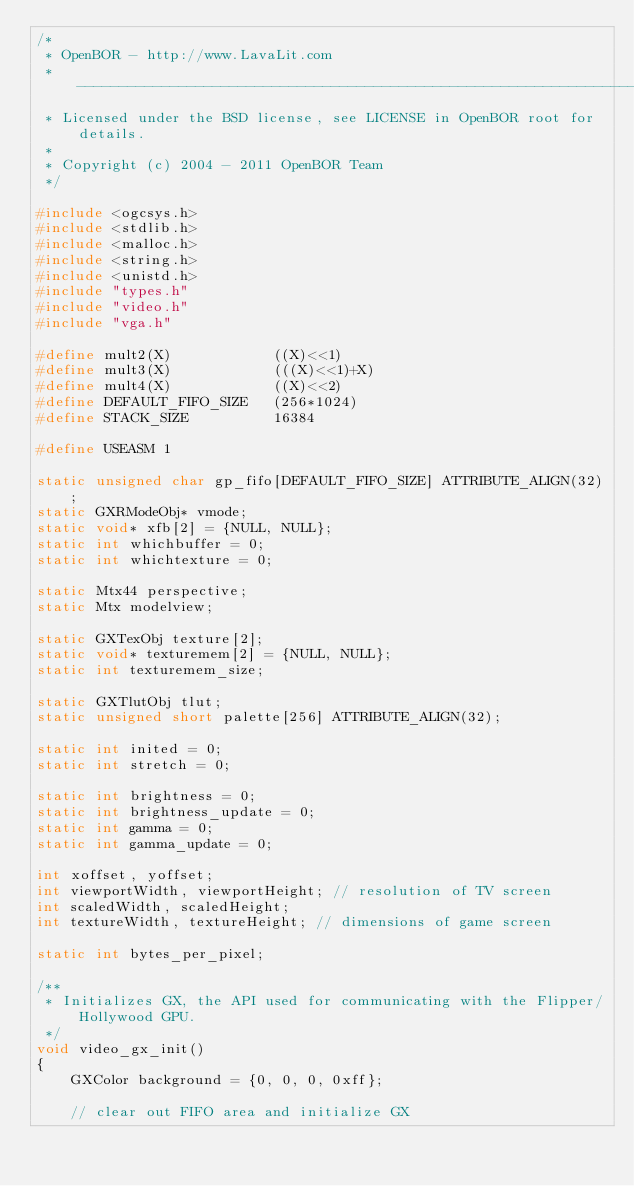Convert code to text. <code><loc_0><loc_0><loc_500><loc_500><_C_>/*
 * OpenBOR - http://www.LavaLit.com
 * -----------------------------------------------------------------------
 * Licensed under the BSD license, see LICENSE in OpenBOR root for details.
 *
 * Copyright (c) 2004 - 2011 OpenBOR Team
 */

#include <ogcsys.h>
#include <stdlib.h>
#include <malloc.h>
#include <string.h>
#include <unistd.h>
#include "types.h"
#include "video.h"
#include "vga.h"

#define mult2(X)			((X)<<1)
#define mult3(X)			(((X)<<1)+X)
#define mult4(X)			((X)<<2)
#define DEFAULT_FIFO_SIZE	(256*1024)
#define STACK_SIZE			16384

#define USEASM 1

static unsigned char gp_fifo[DEFAULT_FIFO_SIZE] ATTRIBUTE_ALIGN(32);
static GXRModeObj* vmode;
static void* xfb[2] = {NULL, NULL};
static int whichbuffer = 0;
static int whichtexture = 0;

static Mtx44 perspective;
static Mtx modelview;

static GXTexObj texture[2];
static void* texturemem[2] = {NULL, NULL};
static int texturemem_size;

static GXTlutObj tlut;
static unsigned short palette[256] ATTRIBUTE_ALIGN(32);

static int inited = 0;
static int stretch = 0;

static int brightness = 0;
static int brightness_update = 0;
static int gamma = 0;
static int gamma_update = 0;

int xoffset, yoffset;
int viewportWidth, viewportHeight; // resolution of TV screen
int scaledWidth, scaledHeight;
int textureWidth, textureHeight; // dimensions of game screen

static int bytes_per_pixel;

/**
 * Initializes GX, the API used for communicating with the Flipper/Hollywood GPU.
 */
void video_gx_init()
{
	GXColor background = {0, 0, 0, 0xff};

	// clear out FIFO area and initialize GX</code> 